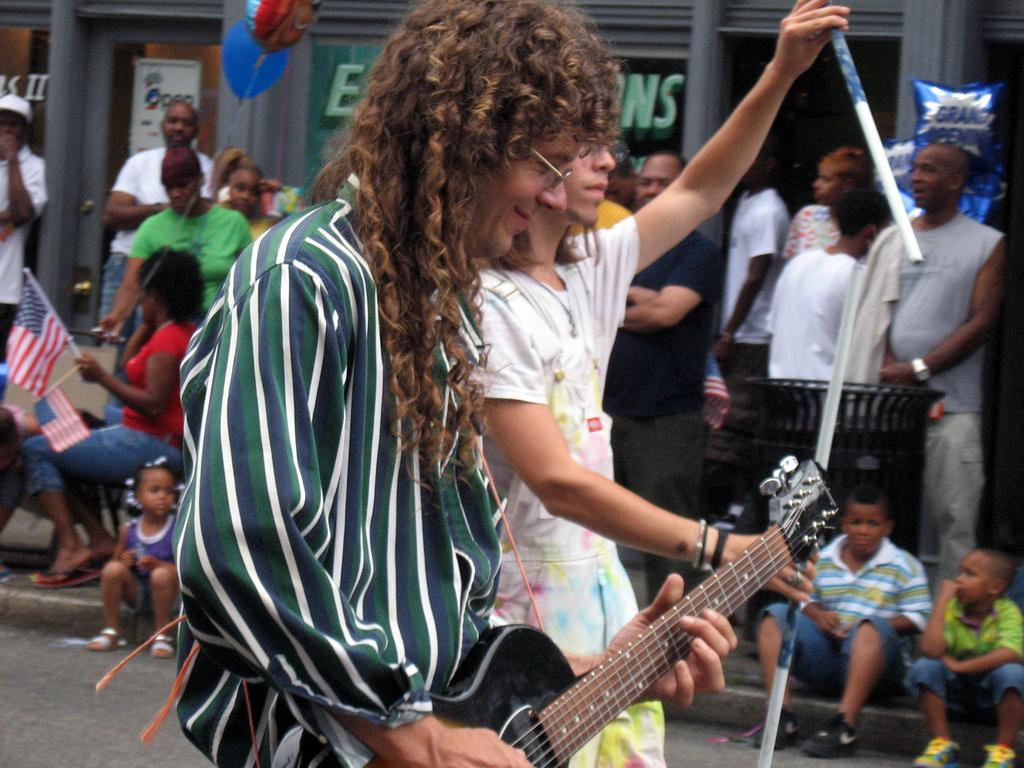Describe this image in one or two sentences. As we can see in the image there are few people standing over, a balloon and a man who is standing here is holding guitar. 